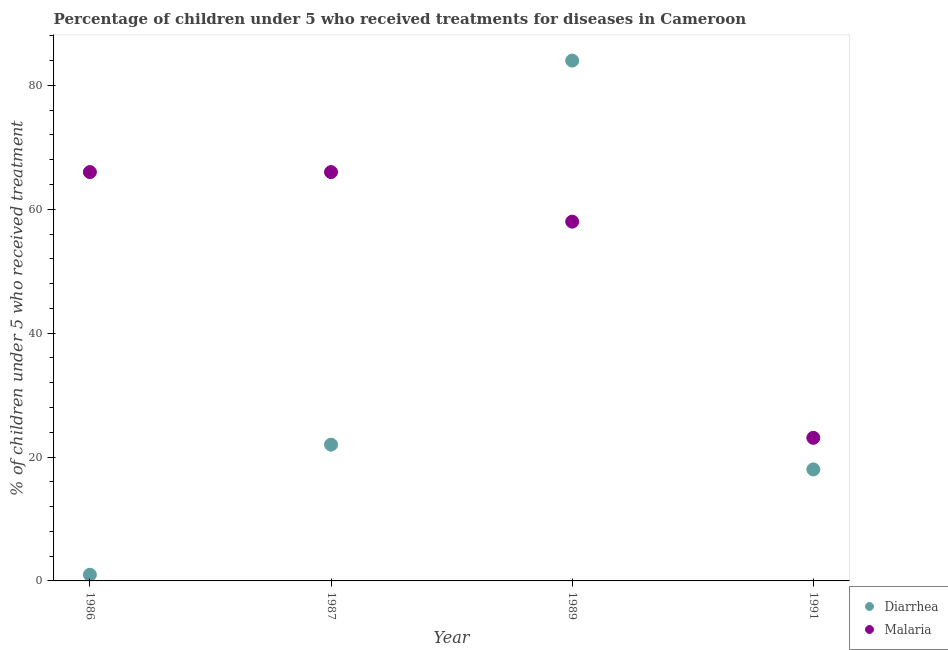How many different coloured dotlines are there?
Give a very brief answer. 2. Across all years, what is the maximum percentage of children who received treatment for malaria?
Provide a succinct answer. 66. Across all years, what is the minimum percentage of children who received treatment for malaria?
Make the answer very short. 23.1. In which year was the percentage of children who received treatment for malaria maximum?
Make the answer very short. 1986. In which year was the percentage of children who received treatment for diarrhoea minimum?
Ensure brevity in your answer.  1986. What is the total percentage of children who received treatment for malaria in the graph?
Your answer should be compact. 213.1. What is the difference between the percentage of children who received treatment for diarrhoea in 1986 and that in 1991?
Your answer should be very brief. -17. What is the average percentage of children who received treatment for malaria per year?
Offer a very short reply. 53.27. What is the ratio of the percentage of children who received treatment for diarrhoea in 1989 to that in 1991?
Your response must be concise. 4.67. Is the percentage of children who received treatment for malaria in 1986 less than that in 1987?
Keep it short and to the point. No. Is the difference between the percentage of children who received treatment for malaria in 1986 and 1991 greater than the difference between the percentage of children who received treatment for diarrhoea in 1986 and 1991?
Provide a short and direct response. Yes. What is the difference between the highest and the second highest percentage of children who received treatment for malaria?
Your answer should be very brief. 0. What is the difference between the highest and the lowest percentage of children who received treatment for diarrhoea?
Offer a very short reply. 83. In how many years, is the percentage of children who received treatment for malaria greater than the average percentage of children who received treatment for malaria taken over all years?
Provide a succinct answer. 3. What is the difference between two consecutive major ticks on the Y-axis?
Ensure brevity in your answer.  20. Does the graph contain grids?
Provide a short and direct response. No. Where does the legend appear in the graph?
Offer a very short reply. Bottom right. What is the title of the graph?
Offer a very short reply. Percentage of children under 5 who received treatments for diseases in Cameroon. Does "Travel services" appear as one of the legend labels in the graph?
Your answer should be very brief. No. What is the label or title of the Y-axis?
Keep it short and to the point. % of children under 5 who received treatment. What is the % of children under 5 who received treatment in Malaria in 1986?
Provide a short and direct response. 66. What is the % of children under 5 who received treatment in Malaria in 1987?
Offer a very short reply. 66. What is the % of children under 5 who received treatment of Diarrhea in 1989?
Provide a succinct answer. 84. What is the % of children under 5 who received treatment in Malaria in 1991?
Offer a terse response. 23.1. Across all years, what is the maximum % of children under 5 who received treatment of Malaria?
Make the answer very short. 66. Across all years, what is the minimum % of children under 5 who received treatment of Diarrhea?
Provide a short and direct response. 1. Across all years, what is the minimum % of children under 5 who received treatment of Malaria?
Your answer should be compact. 23.1. What is the total % of children under 5 who received treatment in Diarrhea in the graph?
Keep it short and to the point. 125. What is the total % of children under 5 who received treatment of Malaria in the graph?
Your answer should be compact. 213.1. What is the difference between the % of children under 5 who received treatment of Diarrhea in 1986 and that in 1987?
Provide a short and direct response. -21. What is the difference between the % of children under 5 who received treatment of Malaria in 1986 and that in 1987?
Give a very brief answer. 0. What is the difference between the % of children under 5 who received treatment in Diarrhea in 1986 and that in 1989?
Keep it short and to the point. -83. What is the difference between the % of children under 5 who received treatment of Malaria in 1986 and that in 1989?
Offer a terse response. 8. What is the difference between the % of children under 5 who received treatment of Diarrhea in 1986 and that in 1991?
Offer a very short reply. -17. What is the difference between the % of children under 5 who received treatment in Malaria in 1986 and that in 1991?
Make the answer very short. 42.9. What is the difference between the % of children under 5 who received treatment in Diarrhea in 1987 and that in 1989?
Your answer should be compact. -62. What is the difference between the % of children under 5 who received treatment in Malaria in 1987 and that in 1991?
Your answer should be compact. 42.9. What is the difference between the % of children under 5 who received treatment of Diarrhea in 1989 and that in 1991?
Keep it short and to the point. 66. What is the difference between the % of children under 5 who received treatment in Malaria in 1989 and that in 1991?
Offer a very short reply. 34.9. What is the difference between the % of children under 5 who received treatment in Diarrhea in 1986 and the % of children under 5 who received treatment in Malaria in 1987?
Ensure brevity in your answer.  -65. What is the difference between the % of children under 5 who received treatment of Diarrhea in 1986 and the % of children under 5 who received treatment of Malaria in 1989?
Your answer should be very brief. -57. What is the difference between the % of children under 5 who received treatment of Diarrhea in 1986 and the % of children under 5 who received treatment of Malaria in 1991?
Your answer should be very brief. -22.1. What is the difference between the % of children under 5 who received treatment in Diarrhea in 1987 and the % of children under 5 who received treatment in Malaria in 1989?
Provide a succinct answer. -36. What is the difference between the % of children under 5 who received treatment of Diarrhea in 1987 and the % of children under 5 who received treatment of Malaria in 1991?
Provide a short and direct response. -1.1. What is the difference between the % of children under 5 who received treatment of Diarrhea in 1989 and the % of children under 5 who received treatment of Malaria in 1991?
Make the answer very short. 60.9. What is the average % of children under 5 who received treatment in Diarrhea per year?
Provide a succinct answer. 31.25. What is the average % of children under 5 who received treatment in Malaria per year?
Keep it short and to the point. 53.27. In the year 1986, what is the difference between the % of children under 5 who received treatment in Diarrhea and % of children under 5 who received treatment in Malaria?
Give a very brief answer. -65. In the year 1987, what is the difference between the % of children under 5 who received treatment in Diarrhea and % of children under 5 who received treatment in Malaria?
Ensure brevity in your answer.  -44. In the year 1989, what is the difference between the % of children under 5 who received treatment of Diarrhea and % of children under 5 who received treatment of Malaria?
Ensure brevity in your answer.  26. In the year 1991, what is the difference between the % of children under 5 who received treatment of Diarrhea and % of children under 5 who received treatment of Malaria?
Your response must be concise. -5.1. What is the ratio of the % of children under 5 who received treatment of Diarrhea in 1986 to that in 1987?
Offer a very short reply. 0.05. What is the ratio of the % of children under 5 who received treatment of Malaria in 1986 to that in 1987?
Provide a succinct answer. 1. What is the ratio of the % of children under 5 who received treatment of Diarrhea in 1986 to that in 1989?
Keep it short and to the point. 0.01. What is the ratio of the % of children under 5 who received treatment in Malaria in 1986 to that in 1989?
Provide a short and direct response. 1.14. What is the ratio of the % of children under 5 who received treatment of Diarrhea in 1986 to that in 1991?
Provide a succinct answer. 0.06. What is the ratio of the % of children under 5 who received treatment of Malaria in 1986 to that in 1991?
Your answer should be compact. 2.86. What is the ratio of the % of children under 5 who received treatment in Diarrhea in 1987 to that in 1989?
Offer a terse response. 0.26. What is the ratio of the % of children under 5 who received treatment of Malaria in 1987 to that in 1989?
Keep it short and to the point. 1.14. What is the ratio of the % of children under 5 who received treatment of Diarrhea in 1987 to that in 1991?
Your answer should be very brief. 1.22. What is the ratio of the % of children under 5 who received treatment of Malaria in 1987 to that in 1991?
Keep it short and to the point. 2.86. What is the ratio of the % of children under 5 who received treatment in Diarrhea in 1989 to that in 1991?
Give a very brief answer. 4.67. What is the ratio of the % of children under 5 who received treatment in Malaria in 1989 to that in 1991?
Your response must be concise. 2.51. What is the difference between the highest and the second highest % of children under 5 who received treatment of Diarrhea?
Offer a terse response. 62. What is the difference between the highest and the second highest % of children under 5 who received treatment of Malaria?
Ensure brevity in your answer.  0. What is the difference between the highest and the lowest % of children under 5 who received treatment of Diarrhea?
Provide a short and direct response. 83. What is the difference between the highest and the lowest % of children under 5 who received treatment of Malaria?
Your answer should be very brief. 42.9. 